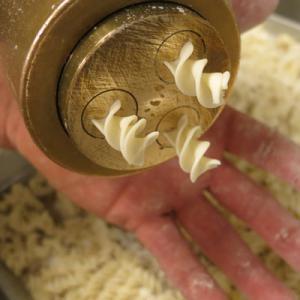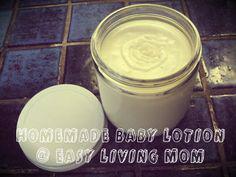The first image is the image on the left, the second image is the image on the right. Given the left and right images, does the statement "Each image shows one open jar filled with a creamy substance, and in one image, a silver lid is leaning at any angle against the edge of the jar." hold true? Answer yes or no. No. 